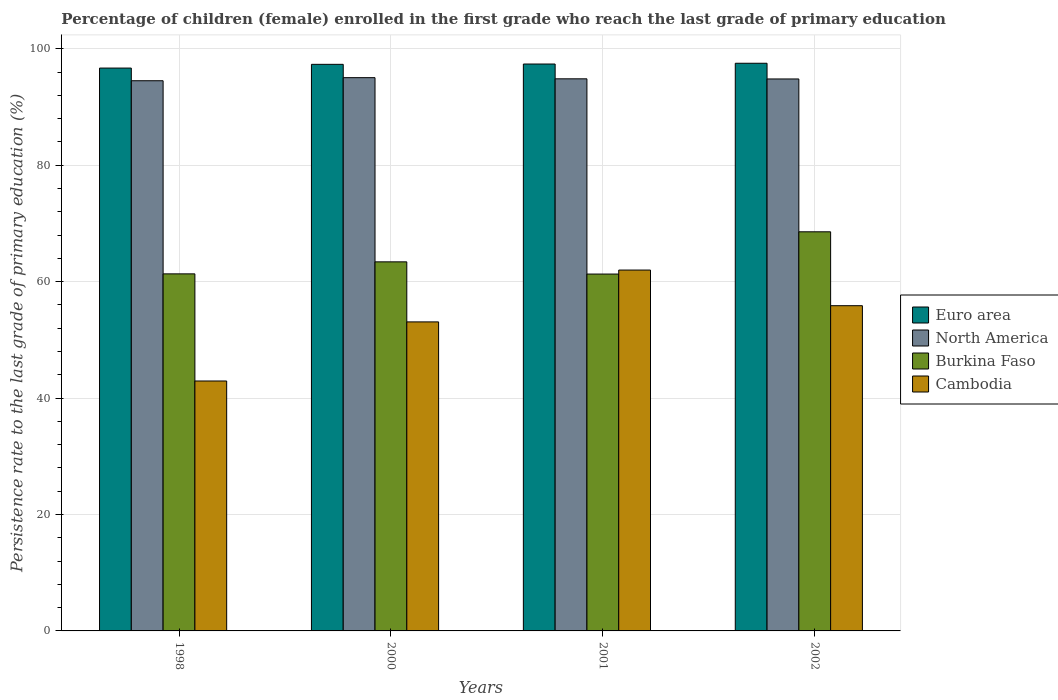How many different coloured bars are there?
Offer a very short reply. 4. Are the number of bars on each tick of the X-axis equal?
Your response must be concise. Yes. How many bars are there on the 1st tick from the left?
Give a very brief answer. 4. What is the label of the 1st group of bars from the left?
Make the answer very short. 1998. What is the persistence rate of children in Euro area in 2000?
Offer a terse response. 97.32. Across all years, what is the maximum persistence rate of children in North America?
Your answer should be very brief. 95.03. Across all years, what is the minimum persistence rate of children in Cambodia?
Keep it short and to the point. 42.93. In which year was the persistence rate of children in Euro area minimum?
Your answer should be very brief. 1998. What is the total persistence rate of children in Cambodia in the graph?
Your response must be concise. 213.85. What is the difference between the persistence rate of children in Euro area in 1998 and that in 2002?
Your answer should be compact. -0.83. What is the difference between the persistence rate of children in North America in 2000 and the persistence rate of children in Cambodia in 1998?
Offer a very short reply. 52.1. What is the average persistence rate of children in Euro area per year?
Offer a terse response. 97.22. In the year 2001, what is the difference between the persistence rate of children in Euro area and persistence rate of children in Burkina Faso?
Your response must be concise. 36.08. What is the ratio of the persistence rate of children in North America in 2000 to that in 2002?
Offer a very short reply. 1. Is the persistence rate of children in North America in 1998 less than that in 2000?
Ensure brevity in your answer.  Yes. What is the difference between the highest and the second highest persistence rate of children in Euro area?
Provide a short and direct response. 0.13. What is the difference between the highest and the lowest persistence rate of children in Euro area?
Provide a succinct answer. 0.83. In how many years, is the persistence rate of children in North America greater than the average persistence rate of children in North America taken over all years?
Ensure brevity in your answer.  3. What does the 3rd bar from the left in 2001 represents?
Provide a short and direct response. Burkina Faso. What does the 4th bar from the right in 2000 represents?
Provide a short and direct response. Euro area. Is it the case that in every year, the sum of the persistence rate of children in Cambodia and persistence rate of children in North America is greater than the persistence rate of children in Euro area?
Keep it short and to the point. Yes. How many bars are there?
Provide a short and direct response. 16. How many years are there in the graph?
Give a very brief answer. 4. Does the graph contain any zero values?
Your answer should be compact. No. How many legend labels are there?
Your answer should be very brief. 4. How are the legend labels stacked?
Give a very brief answer. Vertical. What is the title of the graph?
Give a very brief answer. Percentage of children (female) enrolled in the first grade who reach the last grade of primary education. What is the label or title of the Y-axis?
Provide a short and direct response. Persistence rate to the last grade of primary education (%). What is the Persistence rate to the last grade of primary education (%) of Euro area in 1998?
Offer a very short reply. 96.68. What is the Persistence rate to the last grade of primary education (%) of North America in 1998?
Your answer should be very brief. 94.5. What is the Persistence rate to the last grade of primary education (%) in Burkina Faso in 1998?
Keep it short and to the point. 61.33. What is the Persistence rate to the last grade of primary education (%) in Cambodia in 1998?
Keep it short and to the point. 42.93. What is the Persistence rate to the last grade of primary education (%) of Euro area in 2000?
Give a very brief answer. 97.32. What is the Persistence rate to the last grade of primary education (%) of North America in 2000?
Ensure brevity in your answer.  95.03. What is the Persistence rate to the last grade of primary education (%) of Burkina Faso in 2000?
Offer a very short reply. 63.39. What is the Persistence rate to the last grade of primary education (%) of Cambodia in 2000?
Offer a very short reply. 53.08. What is the Persistence rate to the last grade of primary education (%) of Euro area in 2001?
Your answer should be compact. 97.37. What is the Persistence rate to the last grade of primary education (%) of North America in 2001?
Ensure brevity in your answer.  94.83. What is the Persistence rate to the last grade of primary education (%) in Burkina Faso in 2001?
Your response must be concise. 61.3. What is the Persistence rate to the last grade of primary education (%) of Cambodia in 2001?
Your response must be concise. 61.98. What is the Persistence rate to the last grade of primary education (%) of Euro area in 2002?
Give a very brief answer. 97.5. What is the Persistence rate to the last grade of primary education (%) of North America in 2002?
Offer a terse response. 94.81. What is the Persistence rate to the last grade of primary education (%) in Burkina Faso in 2002?
Your answer should be very brief. 68.55. What is the Persistence rate to the last grade of primary education (%) of Cambodia in 2002?
Offer a terse response. 55.86. Across all years, what is the maximum Persistence rate to the last grade of primary education (%) in Euro area?
Your response must be concise. 97.5. Across all years, what is the maximum Persistence rate to the last grade of primary education (%) of North America?
Provide a short and direct response. 95.03. Across all years, what is the maximum Persistence rate to the last grade of primary education (%) of Burkina Faso?
Offer a very short reply. 68.55. Across all years, what is the maximum Persistence rate to the last grade of primary education (%) of Cambodia?
Provide a short and direct response. 61.98. Across all years, what is the minimum Persistence rate to the last grade of primary education (%) of Euro area?
Ensure brevity in your answer.  96.68. Across all years, what is the minimum Persistence rate to the last grade of primary education (%) of North America?
Your answer should be very brief. 94.5. Across all years, what is the minimum Persistence rate to the last grade of primary education (%) of Burkina Faso?
Your response must be concise. 61.3. Across all years, what is the minimum Persistence rate to the last grade of primary education (%) in Cambodia?
Your answer should be compact. 42.93. What is the total Persistence rate to the last grade of primary education (%) of Euro area in the graph?
Offer a very short reply. 388.87. What is the total Persistence rate to the last grade of primary education (%) of North America in the graph?
Make the answer very short. 379.17. What is the total Persistence rate to the last grade of primary education (%) of Burkina Faso in the graph?
Offer a terse response. 254.57. What is the total Persistence rate to the last grade of primary education (%) of Cambodia in the graph?
Provide a short and direct response. 213.85. What is the difference between the Persistence rate to the last grade of primary education (%) in Euro area in 1998 and that in 2000?
Provide a short and direct response. -0.64. What is the difference between the Persistence rate to the last grade of primary education (%) in North America in 1998 and that in 2000?
Provide a succinct answer. -0.53. What is the difference between the Persistence rate to the last grade of primary education (%) in Burkina Faso in 1998 and that in 2000?
Provide a succinct answer. -2.06. What is the difference between the Persistence rate to the last grade of primary education (%) of Cambodia in 1998 and that in 2000?
Your answer should be compact. -10.15. What is the difference between the Persistence rate to the last grade of primary education (%) in Euro area in 1998 and that in 2001?
Offer a terse response. -0.7. What is the difference between the Persistence rate to the last grade of primary education (%) in North America in 1998 and that in 2001?
Ensure brevity in your answer.  -0.33. What is the difference between the Persistence rate to the last grade of primary education (%) of Burkina Faso in 1998 and that in 2001?
Give a very brief answer. 0.03. What is the difference between the Persistence rate to the last grade of primary education (%) in Cambodia in 1998 and that in 2001?
Your response must be concise. -19.05. What is the difference between the Persistence rate to the last grade of primary education (%) in Euro area in 1998 and that in 2002?
Ensure brevity in your answer.  -0.83. What is the difference between the Persistence rate to the last grade of primary education (%) in North America in 1998 and that in 2002?
Your response must be concise. -0.31. What is the difference between the Persistence rate to the last grade of primary education (%) in Burkina Faso in 1998 and that in 2002?
Offer a very short reply. -7.22. What is the difference between the Persistence rate to the last grade of primary education (%) in Cambodia in 1998 and that in 2002?
Give a very brief answer. -12.93. What is the difference between the Persistence rate to the last grade of primary education (%) of Euro area in 2000 and that in 2001?
Your answer should be very brief. -0.05. What is the difference between the Persistence rate to the last grade of primary education (%) in North America in 2000 and that in 2001?
Offer a terse response. 0.2. What is the difference between the Persistence rate to the last grade of primary education (%) of Burkina Faso in 2000 and that in 2001?
Keep it short and to the point. 2.1. What is the difference between the Persistence rate to the last grade of primary education (%) in Cambodia in 2000 and that in 2001?
Provide a short and direct response. -8.9. What is the difference between the Persistence rate to the last grade of primary education (%) of Euro area in 2000 and that in 2002?
Your response must be concise. -0.19. What is the difference between the Persistence rate to the last grade of primary education (%) of North America in 2000 and that in 2002?
Ensure brevity in your answer.  0.22. What is the difference between the Persistence rate to the last grade of primary education (%) of Burkina Faso in 2000 and that in 2002?
Provide a short and direct response. -5.16. What is the difference between the Persistence rate to the last grade of primary education (%) of Cambodia in 2000 and that in 2002?
Offer a very short reply. -2.78. What is the difference between the Persistence rate to the last grade of primary education (%) in Euro area in 2001 and that in 2002?
Keep it short and to the point. -0.13. What is the difference between the Persistence rate to the last grade of primary education (%) in North America in 2001 and that in 2002?
Give a very brief answer. 0.02. What is the difference between the Persistence rate to the last grade of primary education (%) in Burkina Faso in 2001 and that in 2002?
Offer a very short reply. -7.26. What is the difference between the Persistence rate to the last grade of primary education (%) of Cambodia in 2001 and that in 2002?
Ensure brevity in your answer.  6.12. What is the difference between the Persistence rate to the last grade of primary education (%) of Euro area in 1998 and the Persistence rate to the last grade of primary education (%) of North America in 2000?
Give a very brief answer. 1.65. What is the difference between the Persistence rate to the last grade of primary education (%) in Euro area in 1998 and the Persistence rate to the last grade of primary education (%) in Burkina Faso in 2000?
Your response must be concise. 33.28. What is the difference between the Persistence rate to the last grade of primary education (%) in Euro area in 1998 and the Persistence rate to the last grade of primary education (%) in Cambodia in 2000?
Your response must be concise. 43.6. What is the difference between the Persistence rate to the last grade of primary education (%) in North America in 1998 and the Persistence rate to the last grade of primary education (%) in Burkina Faso in 2000?
Provide a short and direct response. 31.11. What is the difference between the Persistence rate to the last grade of primary education (%) in North America in 1998 and the Persistence rate to the last grade of primary education (%) in Cambodia in 2000?
Provide a short and direct response. 41.42. What is the difference between the Persistence rate to the last grade of primary education (%) in Burkina Faso in 1998 and the Persistence rate to the last grade of primary education (%) in Cambodia in 2000?
Ensure brevity in your answer.  8.25. What is the difference between the Persistence rate to the last grade of primary education (%) in Euro area in 1998 and the Persistence rate to the last grade of primary education (%) in North America in 2001?
Make the answer very short. 1.85. What is the difference between the Persistence rate to the last grade of primary education (%) of Euro area in 1998 and the Persistence rate to the last grade of primary education (%) of Burkina Faso in 2001?
Provide a succinct answer. 35.38. What is the difference between the Persistence rate to the last grade of primary education (%) in Euro area in 1998 and the Persistence rate to the last grade of primary education (%) in Cambodia in 2001?
Make the answer very short. 34.69. What is the difference between the Persistence rate to the last grade of primary education (%) of North America in 1998 and the Persistence rate to the last grade of primary education (%) of Burkina Faso in 2001?
Provide a short and direct response. 33.21. What is the difference between the Persistence rate to the last grade of primary education (%) of North America in 1998 and the Persistence rate to the last grade of primary education (%) of Cambodia in 2001?
Offer a very short reply. 32.52. What is the difference between the Persistence rate to the last grade of primary education (%) in Burkina Faso in 1998 and the Persistence rate to the last grade of primary education (%) in Cambodia in 2001?
Your answer should be compact. -0.65. What is the difference between the Persistence rate to the last grade of primary education (%) in Euro area in 1998 and the Persistence rate to the last grade of primary education (%) in North America in 2002?
Offer a terse response. 1.87. What is the difference between the Persistence rate to the last grade of primary education (%) in Euro area in 1998 and the Persistence rate to the last grade of primary education (%) in Burkina Faso in 2002?
Provide a succinct answer. 28.12. What is the difference between the Persistence rate to the last grade of primary education (%) of Euro area in 1998 and the Persistence rate to the last grade of primary education (%) of Cambodia in 2002?
Keep it short and to the point. 40.82. What is the difference between the Persistence rate to the last grade of primary education (%) of North America in 1998 and the Persistence rate to the last grade of primary education (%) of Burkina Faso in 2002?
Your answer should be very brief. 25.95. What is the difference between the Persistence rate to the last grade of primary education (%) of North America in 1998 and the Persistence rate to the last grade of primary education (%) of Cambodia in 2002?
Provide a short and direct response. 38.64. What is the difference between the Persistence rate to the last grade of primary education (%) in Burkina Faso in 1998 and the Persistence rate to the last grade of primary education (%) in Cambodia in 2002?
Keep it short and to the point. 5.47. What is the difference between the Persistence rate to the last grade of primary education (%) in Euro area in 2000 and the Persistence rate to the last grade of primary education (%) in North America in 2001?
Your response must be concise. 2.49. What is the difference between the Persistence rate to the last grade of primary education (%) in Euro area in 2000 and the Persistence rate to the last grade of primary education (%) in Burkina Faso in 2001?
Keep it short and to the point. 36.02. What is the difference between the Persistence rate to the last grade of primary education (%) in Euro area in 2000 and the Persistence rate to the last grade of primary education (%) in Cambodia in 2001?
Give a very brief answer. 35.34. What is the difference between the Persistence rate to the last grade of primary education (%) of North America in 2000 and the Persistence rate to the last grade of primary education (%) of Burkina Faso in 2001?
Your answer should be very brief. 33.73. What is the difference between the Persistence rate to the last grade of primary education (%) of North America in 2000 and the Persistence rate to the last grade of primary education (%) of Cambodia in 2001?
Keep it short and to the point. 33.05. What is the difference between the Persistence rate to the last grade of primary education (%) in Burkina Faso in 2000 and the Persistence rate to the last grade of primary education (%) in Cambodia in 2001?
Your answer should be very brief. 1.41. What is the difference between the Persistence rate to the last grade of primary education (%) of Euro area in 2000 and the Persistence rate to the last grade of primary education (%) of North America in 2002?
Keep it short and to the point. 2.51. What is the difference between the Persistence rate to the last grade of primary education (%) in Euro area in 2000 and the Persistence rate to the last grade of primary education (%) in Burkina Faso in 2002?
Keep it short and to the point. 28.76. What is the difference between the Persistence rate to the last grade of primary education (%) in Euro area in 2000 and the Persistence rate to the last grade of primary education (%) in Cambodia in 2002?
Keep it short and to the point. 41.46. What is the difference between the Persistence rate to the last grade of primary education (%) in North America in 2000 and the Persistence rate to the last grade of primary education (%) in Burkina Faso in 2002?
Your response must be concise. 26.47. What is the difference between the Persistence rate to the last grade of primary education (%) in North America in 2000 and the Persistence rate to the last grade of primary education (%) in Cambodia in 2002?
Offer a terse response. 39.17. What is the difference between the Persistence rate to the last grade of primary education (%) in Burkina Faso in 2000 and the Persistence rate to the last grade of primary education (%) in Cambodia in 2002?
Provide a short and direct response. 7.53. What is the difference between the Persistence rate to the last grade of primary education (%) in Euro area in 2001 and the Persistence rate to the last grade of primary education (%) in North America in 2002?
Make the answer very short. 2.57. What is the difference between the Persistence rate to the last grade of primary education (%) of Euro area in 2001 and the Persistence rate to the last grade of primary education (%) of Burkina Faso in 2002?
Ensure brevity in your answer.  28.82. What is the difference between the Persistence rate to the last grade of primary education (%) in Euro area in 2001 and the Persistence rate to the last grade of primary education (%) in Cambodia in 2002?
Your response must be concise. 41.51. What is the difference between the Persistence rate to the last grade of primary education (%) in North America in 2001 and the Persistence rate to the last grade of primary education (%) in Burkina Faso in 2002?
Give a very brief answer. 26.28. What is the difference between the Persistence rate to the last grade of primary education (%) of North America in 2001 and the Persistence rate to the last grade of primary education (%) of Cambodia in 2002?
Offer a terse response. 38.97. What is the difference between the Persistence rate to the last grade of primary education (%) of Burkina Faso in 2001 and the Persistence rate to the last grade of primary education (%) of Cambodia in 2002?
Offer a terse response. 5.43. What is the average Persistence rate to the last grade of primary education (%) in Euro area per year?
Your response must be concise. 97.22. What is the average Persistence rate to the last grade of primary education (%) in North America per year?
Your answer should be very brief. 94.79. What is the average Persistence rate to the last grade of primary education (%) of Burkina Faso per year?
Offer a very short reply. 63.64. What is the average Persistence rate to the last grade of primary education (%) of Cambodia per year?
Make the answer very short. 53.46. In the year 1998, what is the difference between the Persistence rate to the last grade of primary education (%) of Euro area and Persistence rate to the last grade of primary education (%) of North America?
Provide a succinct answer. 2.18. In the year 1998, what is the difference between the Persistence rate to the last grade of primary education (%) of Euro area and Persistence rate to the last grade of primary education (%) of Burkina Faso?
Your answer should be compact. 35.35. In the year 1998, what is the difference between the Persistence rate to the last grade of primary education (%) in Euro area and Persistence rate to the last grade of primary education (%) in Cambodia?
Provide a succinct answer. 53.75. In the year 1998, what is the difference between the Persistence rate to the last grade of primary education (%) in North America and Persistence rate to the last grade of primary education (%) in Burkina Faso?
Your answer should be very brief. 33.17. In the year 1998, what is the difference between the Persistence rate to the last grade of primary education (%) of North America and Persistence rate to the last grade of primary education (%) of Cambodia?
Keep it short and to the point. 51.57. In the year 1998, what is the difference between the Persistence rate to the last grade of primary education (%) of Burkina Faso and Persistence rate to the last grade of primary education (%) of Cambodia?
Make the answer very short. 18.4. In the year 2000, what is the difference between the Persistence rate to the last grade of primary education (%) in Euro area and Persistence rate to the last grade of primary education (%) in North America?
Give a very brief answer. 2.29. In the year 2000, what is the difference between the Persistence rate to the last grade of primary education (%) in Euro area and Persistence rate to the last grade of primary education (%) in Burkina Faso?
Provide a short and direct response. 33.93. In the year 2000, what is the difference between the Persistence rate to the last grade of primary education (%) of Euro area and Persistence rate to the last grade of primary education (%) of Cambodia?
Offer a very short reply. 44.24. In the year 2000, what is the difference between the Persistence rate to the last grade of primary education (%) of North America and Persistence rate to the last grade of primary education (%) of Burkina Faso?
Ensure brevity in your answer.  31.64. In the year 2000, what is the difference between the Persistence rate to the last grade of primary education (%) in North America and Persistence rate to the last grade of primary education (%) in Cambodia?
Offer a terse response. 41.95. In the year 2000, what is the difference between the Persistence rate to the last grade of primary education (%) of Burkina Faso and Persistence rate to the last grade of primary education (%) of Cambodia?
Provide a short and direct response. 10.31. In the year 2001, what is the difference between the Persistence rate to the last grade of primary education (%) in Euro area and Persistence rate to the last grade of primary education (%) in North America?
Keep it short and to the point. 2.54. In the year 2001, what is the difference between the Persistence rate to the last grade of primary education (%) in Euro area and Persistence rate to the last grade of primary education (%) in Burkina Faso?
Make the answer very short. 36.08. In the year 2001, what is the difference between the Persistence rate to the last grade of primary education (%) of Euro area and Persistence rate to the last grade of primary education (%) of Cambodia?
Provide a short and direct response. 35.39. In the year 2001, what is the difference between the Persistence rate to the last grade of primary education (%) of North America and Persistence rate to the last grade of primary education (%) of Burkina Faso?
Make the answer very short. 33.54. In the year 2001, what is the difference between the Persistence rate to the last grade of primary education (%) of North America and Persistence rate to the last grade of primary education (%) of Cambodia?
Your response must be concise. 32.85. In the year 2001, what is the difference between the Persistence rate to the last grade of primary education (%) in Burkina Faso and Persistence rate to the last grade of primary education (%) in Cambodia?
Your answer should be compact. -0.69. In the year 2002, what is the difference between the Persistence rate to the last grade of primary education (%) in Euro area and Persistence rate to the last grade of primary education (%) in North America?
Your response must be concise. 2.7. In the year 2002, what is the difference between the Persistence rate to the last grade of primary education (%) in Euro area and Persistence rate to the last grade of primary education (%) in Burkina Faso?
Provide a short and direct response. 28.95. In the year 2002, what is the difference between the Persistence rate to the last grade of primary education (%) of Euro area and Persistence rate to the last grade of primary education (%) of Cambodia?
Offer a very short reply. 41.64. In the year 2002, what is the difference between the Persistence rate to the last grade of primary education (%) of North America and Persistence rate to the last grade of primary education (%) of Burkina Faso?
Your response must be concise. 26.25. In the year 2002, what is the difference between the Persistence rate to the last grade of primary education (%) in North America and Persistence rate to the last grade of primary education (%) in Cambodia?
Make the answer very short. 38.95. In the year 2002, what is the difference between the Persistence rate to the last grade of primary education (%) in Burkina Faso and Persistence rate to the last grade of primary education (%) in Cambodia?
Give a very brief answer. 12.69. What is the ratio of the Persistence rate to the last grade of primary education (%) of North America in 1998 to that in 2000?
Give a very brief answer. 0.99. What is the ratio of the Persistence rate to the last grade of primary education (%) in Burkina Faso in 1998 to that in 2000?
Provide a succinct answer. 0.97. What is the ratio of the Persistence rate to the last grade of primary education (%) in Cambodia in 1998 to that in 2000?
Your answer should be compact. 0.81. What is the ratio of the Persistence rate to the last grade of primary education (%) in Cambodia in 1998 to that in 2001?
Offer a terse response. 0.69. What is the ratio of the Persistence rate to the last grade of primary education (%) in North America in 1998 to that in 2002?
Make the answer very short. 1. What is the ratio of the Persistence rate to the last grade of primary education (%) of Burkina Faso in 1998 to that in 2002?
Give a very brief answer. 0.89. What is the ratio of the Persistence rate to the last grade of primary education (%) of Cambodia in 1998 to that in 2002?
Provide a succinct answer. 0.77. What is the ratio of the Persistence rate to the last grade of primary education (%) in North America in 2000 to that in 2001?
Make the answer very short. 1. What is the ratio of the Persistence rate to the last grade of primary education (%) of Burkina Faso in 2000 to that in 2001?
Keep it short and to the point. 1.03. What is the ratio of the Persistence rate to the last grade of primary education (%) in Cambodia in 2000 to that in 2001?
Your response must be concise. 0.86. What is the ratio of the Persistence rate to the last grade of primary education (%) in Euro area in 2000 to that in 2002?
Your answer should be compact. 1. What is the ratio of the Persistence rate to the last grade of primary education (%) of Burkina Faso in 2000 to that in 2002?
Your response must be concise. 0.92. What is the ratio of the Persistence rate to the last grade of primary education (%) of Cambodia in 2000 to that in 2002?
Provide a succinct answer. 0.95. What is the ratio of the Persistence rate to the last grade of primary education (%) of North America in 2001 to that in 2002?
Keep it short and to the point. 1. What is the ratio of the Persistence rate to the last grade of primary education (%) of Burkina Faso in 2001 to that in 2002?
Keep it short and to the point. 0.89. What is the ratio of the Persistence rate to the last grade of primary education (%) of Cambodia in 2001 to that in 2002?
Provide a short and direct response. 1.11. What is the difference between the highest and the second highest Persistence rate to the last grade of primary education (%) in Euro area?
Keep it short and to the point. 0.13. What is the difference between the highest and the second highest Persistence rate to the last grade of primary education (%) of North America?
Your answer should be compact. 0.2. What is the difference between the highest and the second highest Persistence rate to the last grade of primary education (%) in Burkina Faso?
Ensure brevity in your answer.  5.16. What is the difference between the highest and the second highest Persistence rate to the last grade of primary education (%) in Cambodia?
Offer a terse response. 6.12. What is the difference between the highest and the lowest Persistence rate to the last grade of primary education (%) in Euro area?
Your answer should be very brief. 0.83. What is the difference between the highest and the lowest Persistence rate to the last grade of primary education (%) of North America?
Give a very brief answer. 0.53. What is the difference between the highest and the lowest Persistence rate to the last grade of primary education (%) in Burkina Faso?
Keep it short and to the point. 7.26. What is the difference between the highest and the lowest Persistence rate to the last grade of primary education (%) in Cambodia?
Provide a short and direct response. 19.05. 